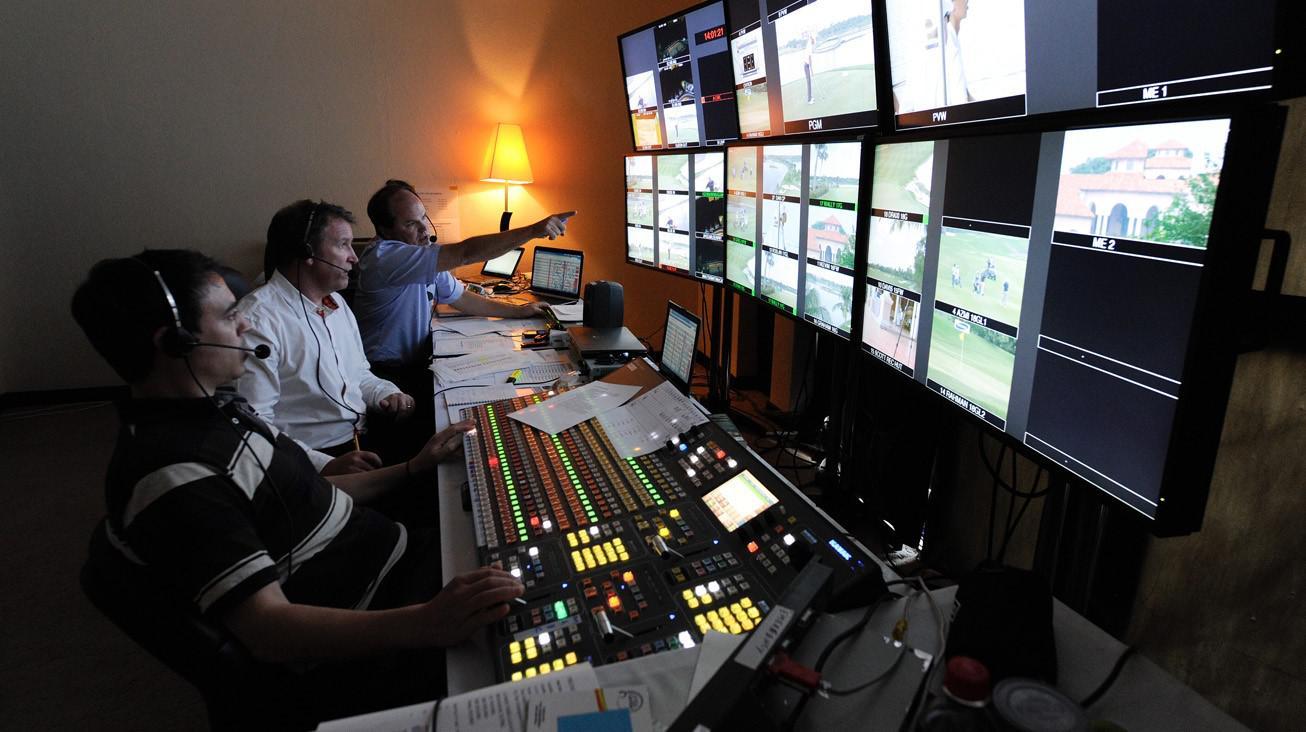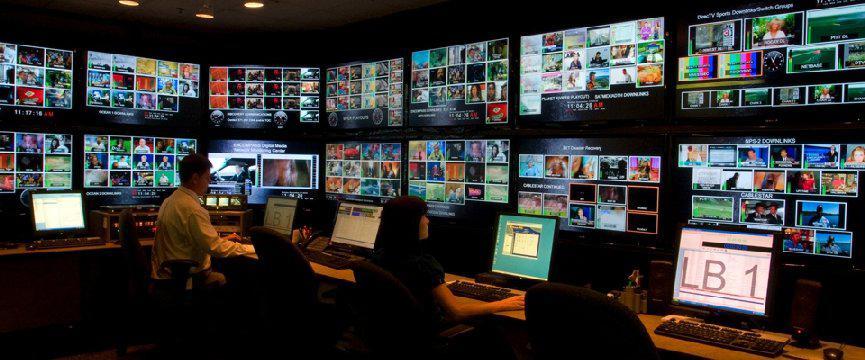The first image is the image on the left, the second image is the image on the right. Evaluate the accuracy of this statement regarding the images: "There is at least one person in the image on the left.". Is it true? Answer yes or no. Yes. 